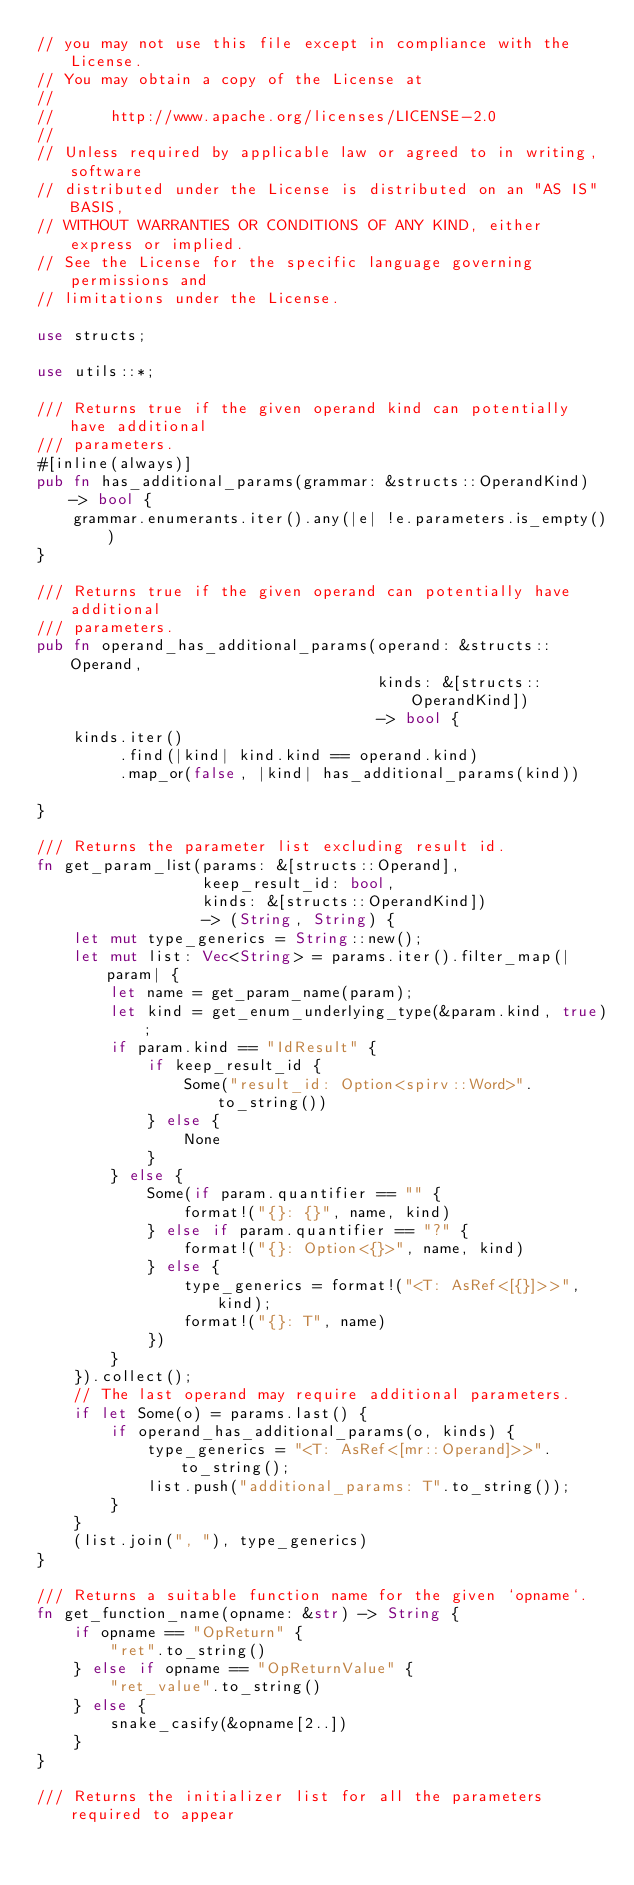<code> <loc_0><loc_0><loc_500><loc_500><_Rust_>// you may not use this file except in compliance with the License.
// You may obtain a copy of the License at
//
//      http://www.apache.org/licenses/LICENSE-2.0
//
// Unless required by applicable law or agreed to in writing, software
// distributed under the License is distributed on an "AS IS" BASIS,
// WITHOUT WARRANTIES OR CONDITIONS OF ANY KIND, either express or implied.
// See the License for the specific language governing permissions and
// limitations under the License.

use structs;

use utils::*;

/// Returns true if the given operand kind can potentially have additional
/// parameters.
#[inline(always)]
pub fn has_additional_params(grammar: &structs::OperandKind) -> bool {
    grammar.enumerants.iter().any(|e| !e.parameters.is_empty())
}

/// Returns true if the given operand can potentially have additional
/// parameters.
pub fn operand_has_additional_params(operand: &structs::Operand,
                                     kinds: &[structs::OperandKind])
                                     -> bool {
    kinds.iter()
         .find(|kind| kind.kind == operand.kind)
         .map_or(false, |kind| has_additional_params(kind))

}

/// Returns the parameter list excluding result id.
fn get_param_list(params: &[structs::Operand],
                  keep_result_id: bool,
                  kinds: &[structs::OperandKind])
                  -> (String, String) {
    let mut type_generics = String::new();
    let mut list: Vec<String> = params.iter().filter_map(|param| {
        let name = get_param_name(param);
        let kind = get_enum_underlying_type(&param.kind, true);
        if param.kind == "IdResult" {
            if keep_result_id {
                Some("result_id: Option<spirv::Word>".to_string())
            } else {
                None
            }
        } else {
            Some(if param.quantifier == "" {
                format!("{}: {}", name, kind)
            } else if param.quantifier == "?" {
                format!("{}: Option<{}>", name, kind)
            } else {
                type_generics = format!("<T: AsRef<[{}]>>", kind);
                format!("{}: T", name)
            })
        }
    }).collect();
    // The last operand may require additional parameters.
    if let Some(o) = params.last() {
        if operand_has_additional_params(o, kinds) {
            type_generics = "<T: AsRef<[mr::Operand]>>".to_string();
            list.push("additional_params: T".to_string());
        }
    }
    (list.join(", "), type_generics)
}

/// Returns a suitable function name for the given `opname`.
fn get_function_name(opname: &str) -> String {
    if opname == "OpReturn" {
        "ret".to_string()
    } else if opname == "OpReturnValue" {
        "ret_value".to_string()
    } else {
        snake_casify(&opname[2..])
    }
}

/// Returns the initializer list for all the parameters required to appear</code> 